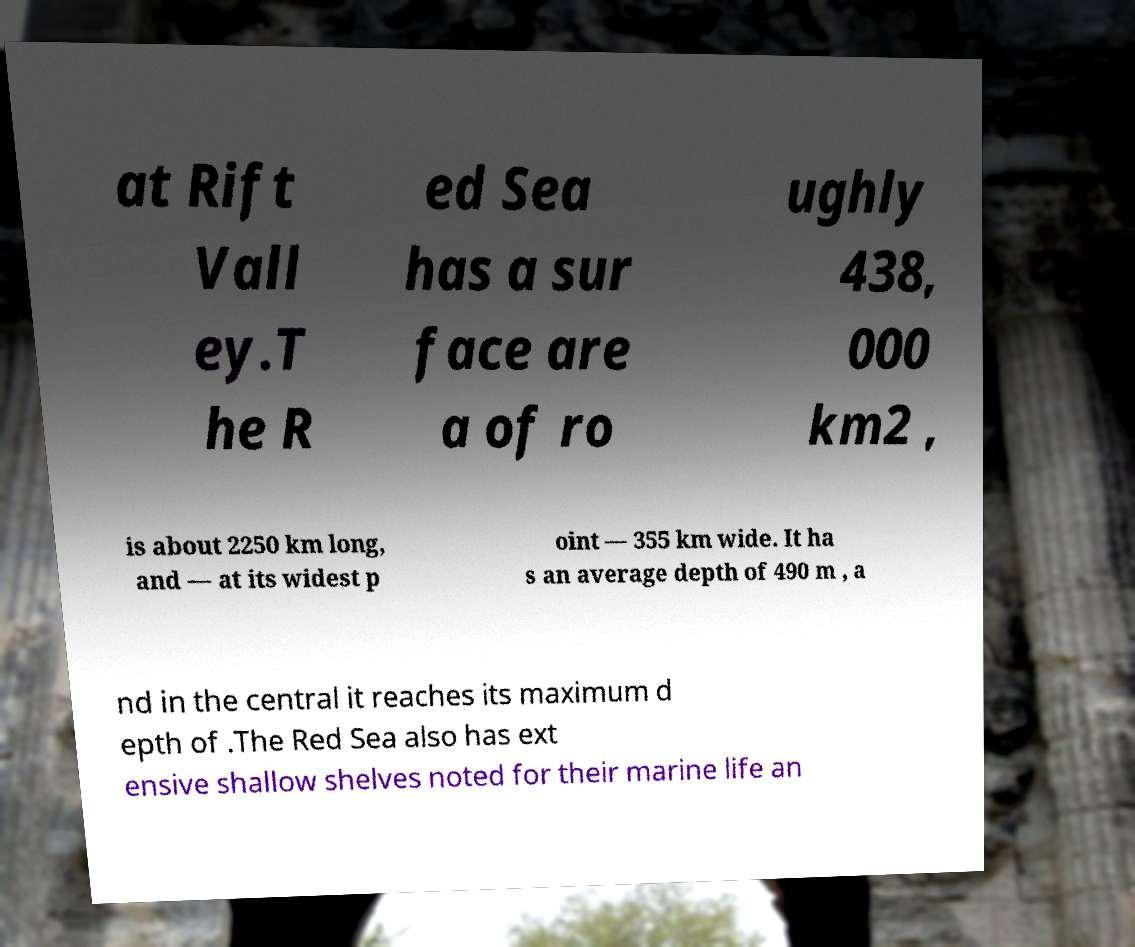I need the written content from this picture converted into text. Can you do that? at Rift Vall ey.T he R ed Sea has a sur face are a of ro ughly 438, 000 km2 , is about 2250 km long, and — at its widest p oint — 355 km wide. It ha s an average depth of 490 m , a nd in the central it reaches its maximum d epth of .The Red Sea also has ext ensive shallow shelves noted for their marine life an 